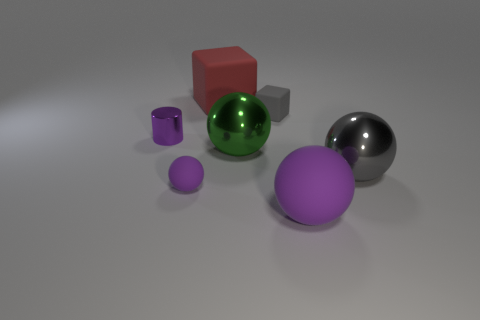There is a purple thing right of the small rubber thing that is to the left of the red block; what shape is it? The purple object to the right of the small rubber item, which is left of the red block, is a sphere, showcasing a smooth, round surface that reflects light evenly across its curves. 